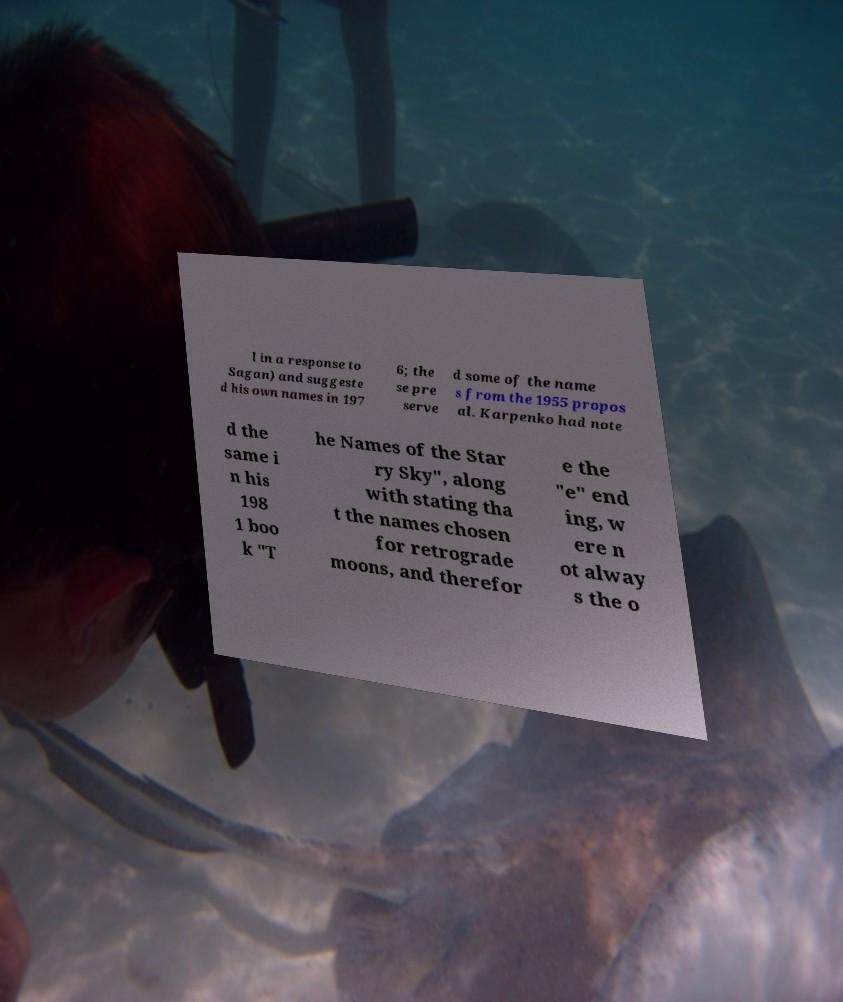Could you extract and type out the text from this image? l in a response to Sagan) and suggeste d his own names in 197 6; the se pre serve d some of the name s from the 1955 propos al. Karpenko had note d the same i n his 198 1 boo k "T he Names of the Star ry Sky", along with stating tha t the names chosen for retrograde moons, and therefor e the "e" end ing, w ere n ot alway s the o 